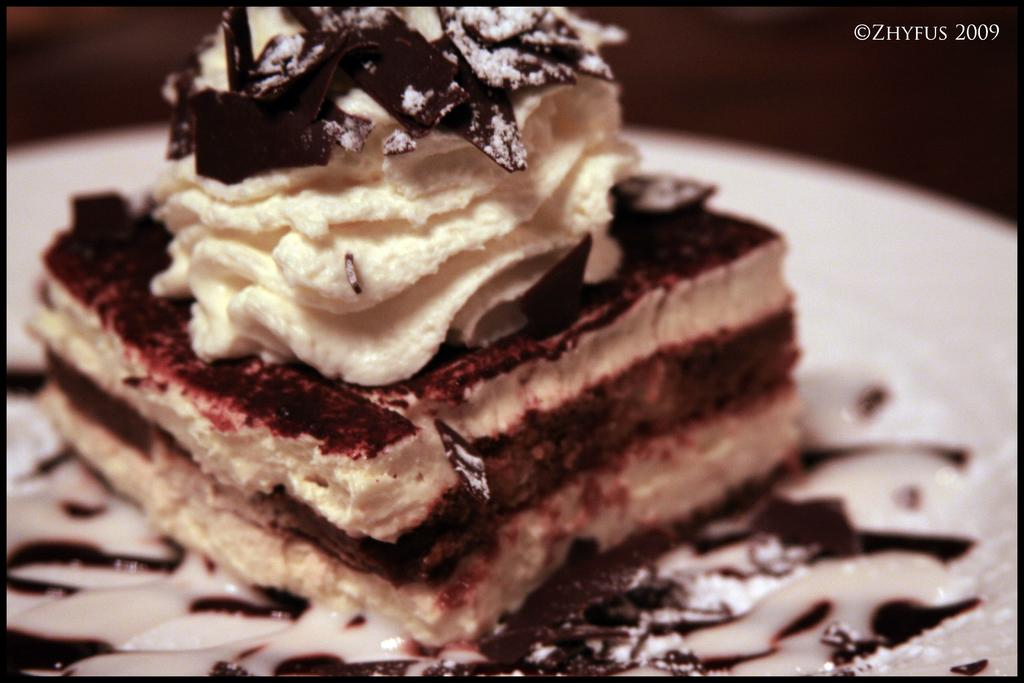What type of dessert is featured in the image? There is a piece of cake with cream on it in the image. What is the color of the surface the cake is placed on? The cake is on a white surface. Is there any text present in the image? Yes, there is text in the top right corner of the image. What type of stone is visible in the image? There is no stone present in the image. What is the angle of the cake in the image? The angle of the cake cannot be determined from the image, as it is a flat, two-dimensional representation. 